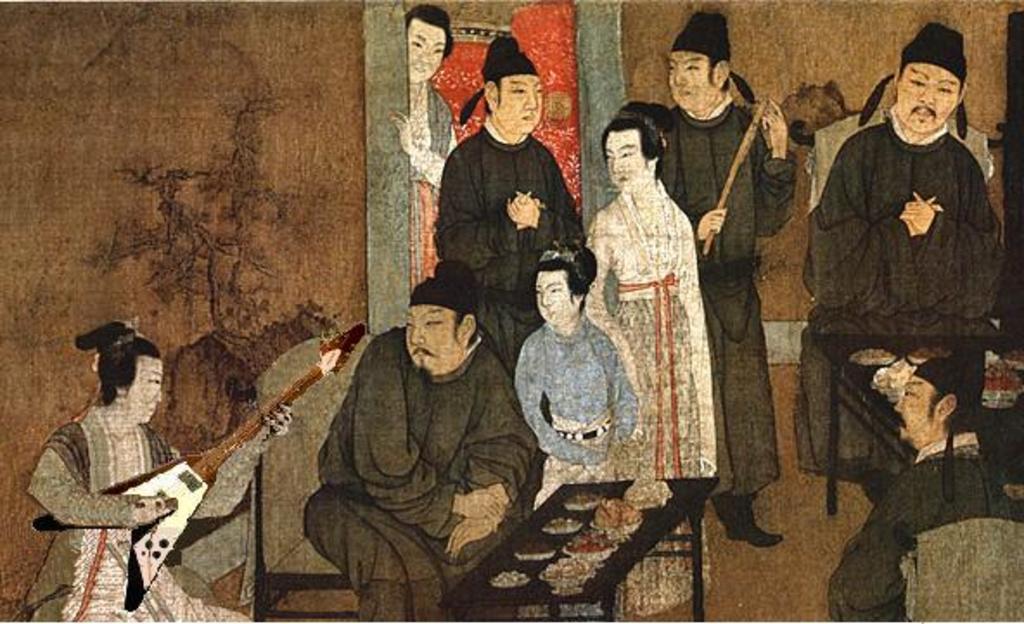Describe this image in one or two sentences. As we can see in the image is a painting of few people, wall, chairs and tables. The woman on the left side is holding a guitar and on tables there are dishes. 